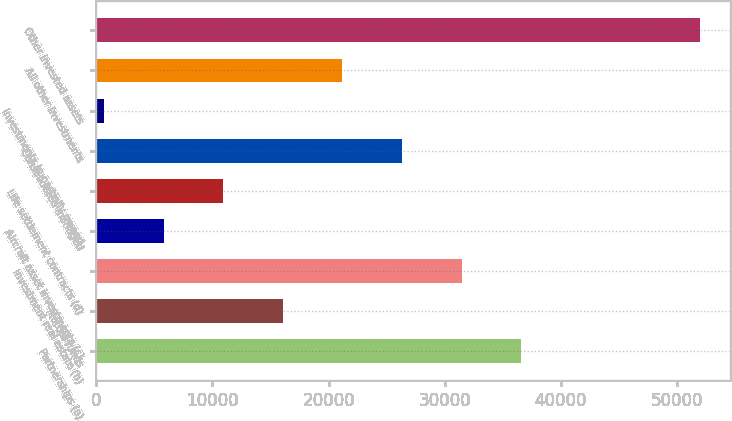Convert chart. <chart><loc_0><loc_0><loc_500><loc_500><bar_chart><fcel>Partnerships (a)<fcel>Mutual funds<fcel>Investment real estate (b)<fcel>Aircraft asset investments (c)<fcel>Life settlement contracts (d)<fcel>Consolidated managed<fcel>Investments in partially owned<fcel>All other investments<fcel>Other invested assets<nl><fcel>36579.3<fcel>16047.7<fcel>31446.4<fcel>5781.9<fcel>10914.8<fcel>26313.5<fcel>649<fcel>21180.6<fcel>51978<nl></chart> 